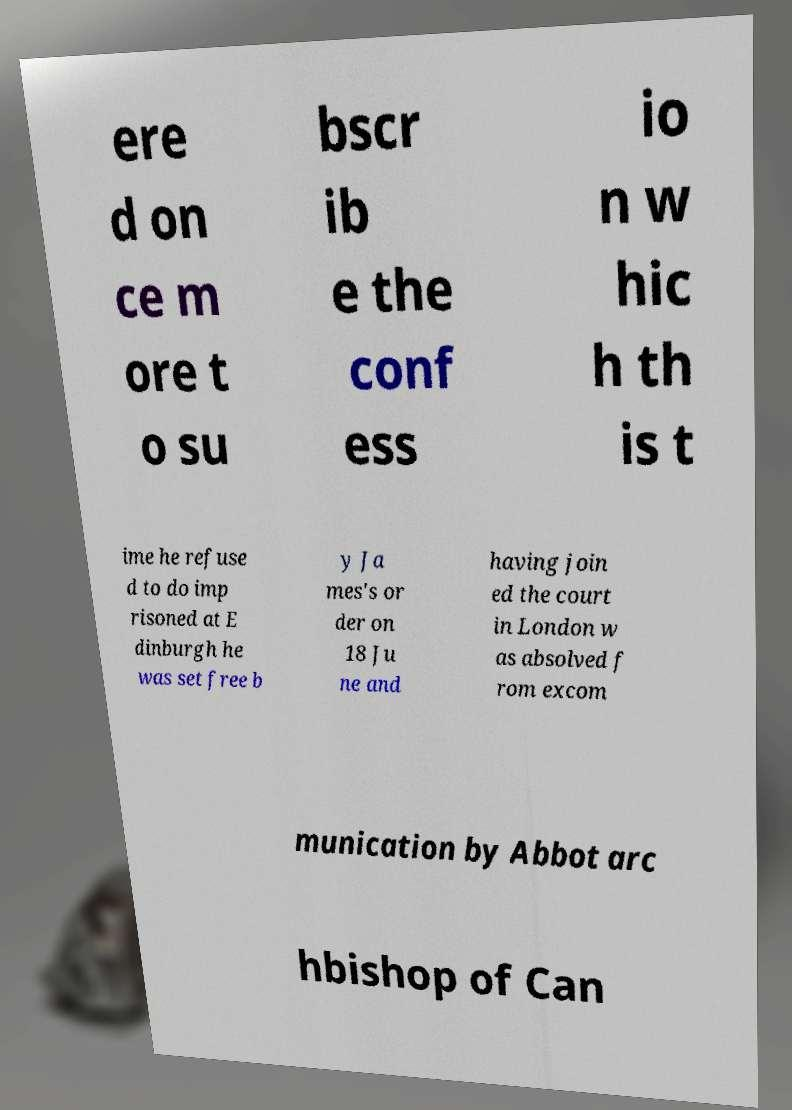Can you read and provide the text displayed in the image?This photo seems to have some interesting text. Can you extract and type it out for me? ere d on ce m ore t o su bscr ib e the conf ess io n w hic h th is t ime he refuse d to do imp risoned at E dinburgh he was set free b y Ja mes's or der on 18 Ju ne and having join ed the court in London w as absolved f rom excom munication by Abbot arc hbishop of Can 